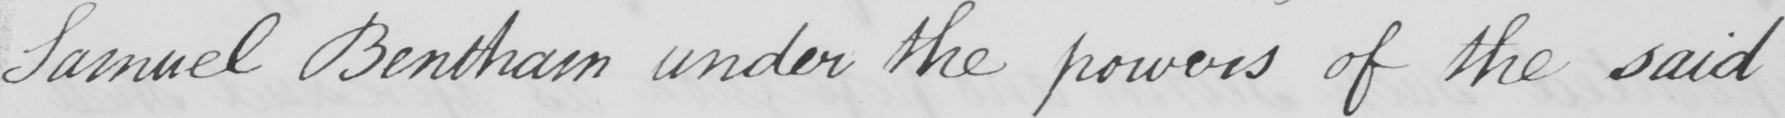What is written in this line of handwriting? Samuel Bentham under the powers of the said 